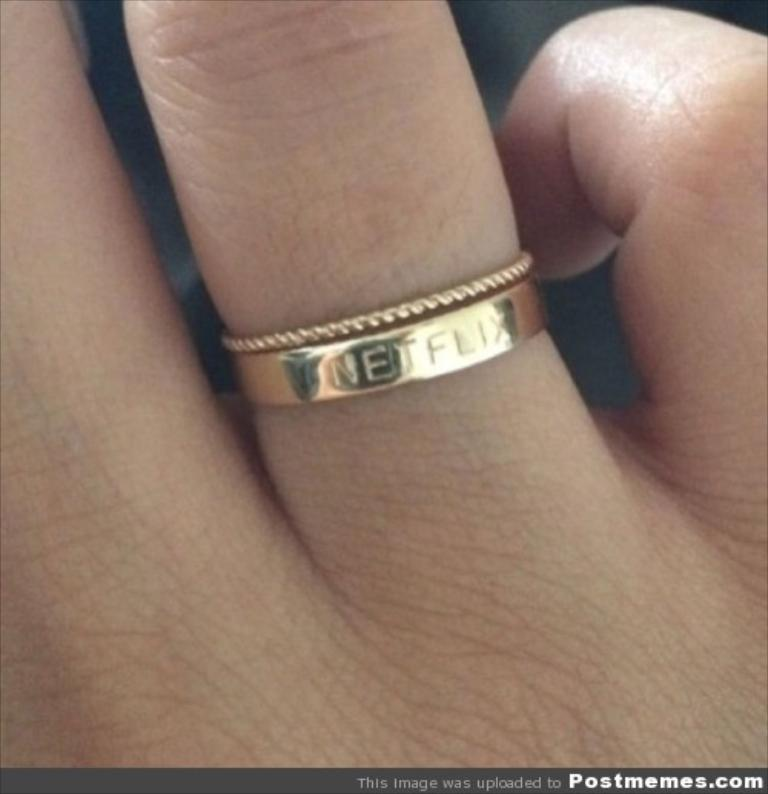What type of jewelry is depicted in the image? The object is a hand ring for the finger. Can you describe any unique features or characteristics of the hand ring? Unfortunately, the image only shows the hand ring, and no specific features or characteristics are visible. What type of seed is growing in the ground in the image? There is no ground or seed present in the image; it only shows a hand ring for the finger. 